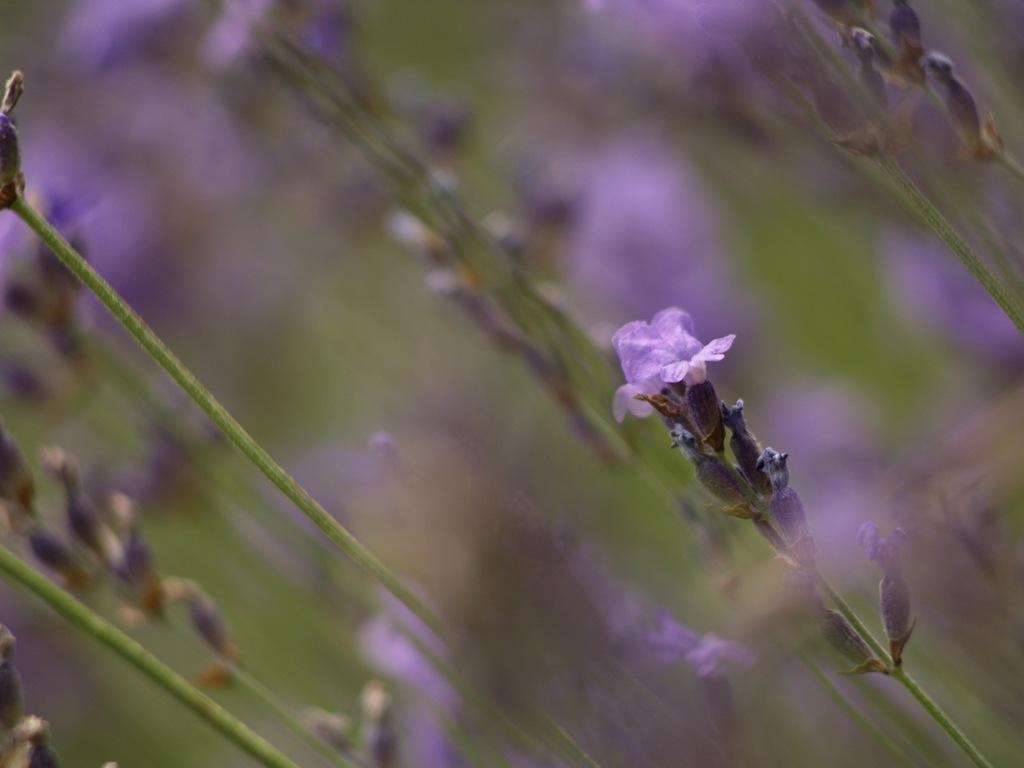Please provide a concise description of this image. This is an edited image. In this image we can see plants with flowers. 